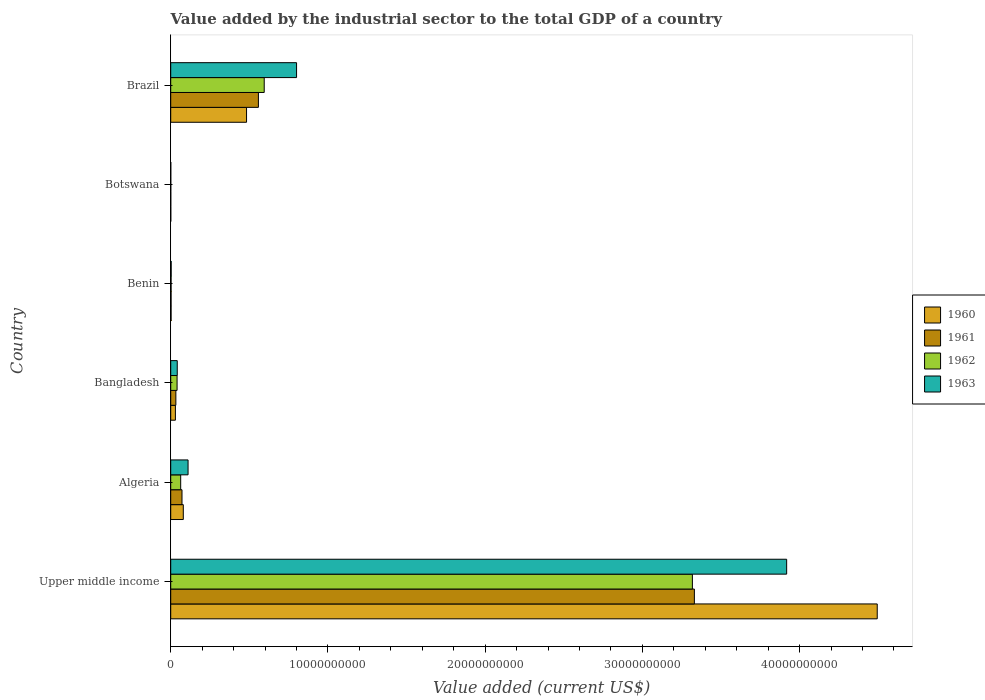How many different coloured bars are there?
Make the answer very short. 4. What is the label of the 4th group of bars from the top?
Your answer should be very brief. Bangladesh. What is the value added by the industrial sector to the total GDP in 1963 in Upper middle income?
Your answer should be compact. 3.92e+1. Across all countries, what is the maximum value added by the industrial sector to the total GDP in 1961?
Provide a succinct answer. 3.33e+1. Across all countries, what is the minimum value added by the industrial sector to the total GDP in 1962?
Your answer should be very brief. 4.05e+06. In which country was the value added by the industrial sector to the total GDP in 1963 maximum?
Ensure brevity in your answer.  Upper middle income. In which country was the value added by the industrial sector to the total GDP in 1961 minimum?
Give a very brief answer. Botswana. What is the total value added by the industrial sector to the total GDP in 1963 in the graph?
Your response must be concise. 4.87e+1. What is the difference between the value added by the industrial sector to the total GDP in 1962 in Benin and that in Botswana?
Make the answer very short. 1.91e+07. What is the difference between the value added by the industrial sector to the total GDP in 1963 in Botswana and the value added by the industrial sector to the total GDP in 1961 in Upper middle income?
Ensure brevity in your answer.  -3.33e+1. What is the average value added by the industrial sector to the total GDP in 1963 per country?
Offer a terse response. 8.12e+09. What is the difference between the value added by the industrial sector to the total GDP in 1960 and value added by the industrial sector to the total GDP in 1962 in Benin?
Keep it short and to the point. -1.71e+04. In how many countries, is the value added by the industrial sector to the total GDP in 1962 greater than 32000000000 US$?
Your answer should be compact. 1. What is the ratio of the value added by the industrial sector to the total GDP in 1960 in Benin to that in Botswana?
Offer a terse response. 5.71. What is the difference between the highest and the second highest value added by the industrial sector to the total GDP in 1961?
Offer a terse response. 2.77e+1. What is the difference between the highest and the lowest value added by the industrial sector to the total GDP in 1962?
Offer a terse response. 3.32e+1. In how many countries, is the value added by the industrial sector to the total GDP in 1961 greater than the average value added by the industrial sector to the total GDP in 1961 taken over all countries?
Provide a succinct answer. 1. Is the sum of the value added by the industrial sector to the total GDP in 1961 in Bangladesh and Upper middle income greater than the maximum value added by the industrial sector to the total GDP in 1962 across all countries?
Offer a terse response. Yes. Is it the case that in every country, the sum of the value added by the industrial sector to the total GDP in 1963 and value added by the industrial sector to the total GDP in 1961 is greater than the sum of value added by the industrial sector to the total GDP in 1962 and value added by the industrial sector to the total GDP in 1960?
Make the answer very short. No. What does the 3rd bar from the bottom in Brazil represents?
Keep it short and to the point. 1962. Is it the case that in every country, the sum of the value added by the industrial sector to the total GDP in 1963 and value added by the industrial sector to the total GDP in 1961 is greater than the value added by the industrial sector to the total GDP in 1960?
Your answer should be compact. Yes. Are all the bars in the graph horizontal?
Your answer should be compact. Yes. How many countries are there in the graph?
Your answer should be compact. 6. How are the legend labels stacked?
Provide a succinct answer. Vertical. What is the title of the graph?
Your response must be concise. Value added by the industrial sector to the total GDP of a country. What is the label or title of the X-axis?
Give a very brief answer. Value added (current US$). What is the Value added (current US$) in 1960 in Upper middle income?
Your answer should be compact. 4.49e+1. What is the Value added (current US$) of 1961 in Upper middle income?
Provide a succinct answer. 3.33e+1. What is the Value added (current US$) of 1962 in Upper middle income?
Offer a very short reply. 3.32e+1. What is the Value added (current US$) in 1963 in Upper middle income?
Ensure brevity in your answer.  3.92e+1. What is the Value added (current US$) in 1960 in Algeria?
Provide a succinct answer. 8.00e+08. What is the Value added (current US$) of 1961 in Algeria?
Your answer should be compact. 7.17e+08. What is the Value added (current US$) of 1962 in Algeria?
Ensure brevity in your answer.  6.34e+08. What is the Value added (current US$) in 1963 in Algeria?
Keep it short and to the point. 1.10e+09. What is the Value added (current US$) of 1960 in Bangladesh?
Give a very brief answer. 2.98e+08. What is the Value added (current US$) of 1961 in Bangladesh?
Give a very brief answer. 3.27e+08. What is the Value added (current US$) in 1962 in Bangladesh?
Make the answer very short. 4.05e+08. What is the Value added (current US$) of 1963 in Bangladesh?
Your response must be concise. 4.15e+08. What is the Value added (current US$) of 1960 in Benin?
Make the answer very short. 2.31e+07. What is the Value added (current US$) in 1961 in Benin?
Ensure brevity in your answer.  2.31e+07. What is the Value added (current US$) of 1962 in Benin?
Your answer should be very brief. 2.32e+07. What is the Value added (current US$) in 1963 in Benin?
Your answer should be very brief. 2.91e+07. What is the Value added (current US$) in 1960 in Botswana?
Your answer should be compact. 4.05e+06. What is the Value added (current US$) of 1961 in Botswana?
Provide a succinct answer. 4.05e+06. What is the Value added (current US$) in 1962 in Botswana?
Provide a short and direct response. 4.05e+06. What is the Value added (current US$) of 1963 in Botswana?
Keep it short and to the point. 4.04e+06. What is the Value added (current US$) of 1960 in Brazil?
Your response must be concise. 4.82e+09. What is the Value added (current US$) in 1961 in Brazil?
Your response must be concise. 5.58e+09. What is the Value added (current US$) in 1962 in Brazil?
Ensure brevity in your answer.  5.95e+09. What is the Value added (current US$) in 1963 in Brazil?
Offer a terse response. 8.00e+09. Across all countries, what is the maximum Value added (current US$) of 1960?
Offer a very short reply. 4.49e+1. Across all countries, what is the maximum Value added (current US$) of 1961?
Give a very brief answer. 3.33e+1. Across all countries, what is the maximum Value added (current US$) in 1962?
Offer a very short reply. 3.32e+1. Across all countries, what is the maximum Value added (current US$) of 1963?
Make the answer very short. 3.92e+1. Across all countries, what is the minimum Value added (current US$) in 1960?
Your answer should be compact. 4.05e+06. Across all countries, what is the minimum Value added (current US$) of 1961?
Offer a terse response. 4.05e+06. Across all countries, what is the minimum Value added (current US$) of 1962?
Your answer should be compact. 4.05e+06. Across all countries, what is the minimum Value added (current US$) in 1963?
Provide a succinct answer. 4.04e+06. What is the total Value added (current US$) in 1960 in the graph?
Offer a terse response. 5.09e+1. What is the total Value added (current US$) in 1961 in the graph?
Offer a very short reply. 4.00e+1. What is the total Value added (current US$) of 1962 in the graph?
Your answer should be compact. 4.02e+1. What is the total Value added (current US$) in 1963 in the graph?
Provide a short and direct response. 4.87e+1. What is the difference between the Value added (current US$) in 1960 in Upper middle income and that in Algeria?
Provide a succinct answer. 4.41e+1. What is the difference between the Value added (current US$) of 1961 in Upper middle income and that in Algeria?
Provide a short and direct response. 3.26e+1. What is the difference between the Value added (current US$) of 1962 in Upper middle income and that in Algeria?
Offer a very short reply. 3.25e+1. What is the difference between the Value added (current US$) in 1963 in Upper middle income and that in Algeria?
Provide a short and direct response. 3.81e+1. What is the difference between the Value added (current US$) of 1960 in Upper middle income and that in Bangladesh?
Keep it short and to the point. 4.46e+1. What is the difference between the Value added (current US$) of 1961 in Upper middle income and that in Bangladesh?
Offer a terse response. 3.30e+1. What is the difference between the Value added (current US$) in 1962 in Upper middle income and that in Bangladesh?
Ensure brevity in your answer.  3.28e+1. What is the difference between the Value added (current US$) in 1963 in Upper middle income and that in Bangladesh?
Ensure brevity in your answer.  3.88e+1. What is the difference between the Value added (current US$) of 1960 in Upper middle income and that in Benin?
Your answer should be compact. 4.49e+1. What is the difference between the Value added (current US$) of 1961 in Upper middle income and that in Benin?
Keep it short and to the point. 3.33e+1. What is the difference between the Value added (current US$) of 1962 in Upper middle income and that in Benin?
Provide a succinct answer. 3.32e+1. What is the difference between the Value added (current US$) of 1963 in Upper middle income and that in Benin?
Your response must be concise. 3.91e+1. What is the difference between the Value added (current US$) of 1960 in Upper middle income and that in Botswana?
Your response must be concise. 4.49e+1. What is the difference between the Value added (current US$) in 1961 in Upper middle income and that in Botswana?
Your answer should be very brief. 3.33e+1. What is the difference between the Value added (current US$) in 1962 in Upper middle income and that in Botswana?
Your answer should be compact. 3.32e+1. What is the difference between the Value added (current US$) of 1963 in Upper middle income and that in Botswana?
Ensure brevity in your answer.  3.92e+1. What is the difference between the Value added (current US$) of 1960 in Upper middle income and that in Brazil?
Offer a terse response. 4.01e+1. What is the difference between the Value added (current US$) of 1961 in Upper middle income and that in Brazil?
Ensure brevity in your answer.  2.77e+1. What is the difference between the Value added (current US$) of 1962 in Upper middle income and that in Brazil?
Ensure brevity in your answer.  2.72e+1. What is the difference between the Value added (current US$) in 1963 in Upper middle income and that in Brazil?
Keep it short and to the point. 3.12e+1. What is the difference between the Value added (current US$) of 1960 in Algeria and that in Bangladesh?
Ensure brevity in your answer.  5.02e+08. What is the difference between the Value added (current US$) of 1961 in Algeria and that in Bangladesh?
Offer a terse response. 3.90e+08. What is the difference between the Value added (current US$) of 1962 in Algeria and that in Bangladesh?
Offer a very short reply. 2.30e+08. What is the difference between the Value added (current US$) of 1963 in Algeria and that in Bangladesh?
Your answer should be compact. 6.88e+08. What is the difference between the Value added (current US$) in 1960 in Algeria and that in Benin?
Provide a succinct answer. 7.77e+08. What is the difference between the Value added (current US$) of 1961 in Algeria and that in Benin?
Ensure brevity in your answer.  6.94e+08. What is the difference between the Value added (current US$) in 1962 in Algeria and that in Benin?
Provide a short and direct response. 6.11e+08. What is the difference between the Value added (current US$) in 1963 in Algeria and that in Benin?
Your answer should be very brief. 1.07e+09. What is the difference between the Value added (current US$) in 1960 in Algeria and that in Botswana?
Offer a very short reply. 7.96e+08. What is the difference between the Value added (current US$) in 1961 in Algeria and that in Botswana?
Your response must be concise. 7.13e+08. What is the difference between the Value added (current US$) of 1962 in Algeria and that in Botswana?
Offer a terse response. 6.30e+08. What is the difference between the Value added (current US$) of 1963 in Algeria and that in Botswana?
Provide a short and direct response. 1.10e+09. What is the difference between the Value added (current US$) of 1960 in Algeria and that in Brazil?
Your answer should be compact. -4.02e+09. What is the difference between the Value added (current US$) in 1961 in Algeria and that in Brazil?
Your response must be concise. -4.86e+09. What is the difference between the Value added (current US$) of 1962 in Algeria and that in Brazil?
Your answer should be compact. -5.31e+09. What is the difference between the Value added (current US$) in 1963 in Algeria and that in Brazil?
Make the answer very short. -6.90e+09. What is the difference between the Value added (current US$) in 1960 in Bangladesh and that in Benin?
Keep it short and to the point. 2.75e+08. What is the difference between the Value added (current US$) in 1961 in Bangladesh and that in Benin?
Keep it short and to the point. 3.04e+08. What is the difference between the Value added (current US$) of 1962 in Bangladesh and that in Benin?
Your response must be concise. 3.82e+08. What is the difference between the Value added (current US$) in 1963 in Bangladesh and that in Benin?
Your response must be concise. 3.86e+08. What is the difference between the Value added (current US$) of 1960 in Bangladesh and that in Botswana?
Your answer should be compact. 2.94e+08. What is the difference between the Value added (current US$) of 1961 in Bangladesh and that in Botswana?
Your response must be concise. 3.23e+08. What is the difference between the Value added (current US$) in 1962 in Bangladesh and that in Botswana?
Give a very brief answer. 4.01e+08. What is the difference between the Value added (current US$) in 1963 in Bangladesh and that in Botswana?
Provide a short and direct response. 4.11e+08. What is the difference between the Value added (current US$) in 1960 in Bangladesh and that in Brazil?
Offer a very short reply. -4.52e+09. What is the difference between the Value added (current US$) of 1961 in Bangladesh and that in Brazil?
Give a very brief answer. -5.25e+09. What is the difference between the Value added (current US$) in 1962 in Bangladesh and that in Brazil?
Provide a short and direct response. -5.54e+09. What is the difference between the Value added (current US$) in 1963 in Bangladesh and that in Brazil?
Offer a terse response. -7.59e+09. What is the difference between the Value added (current US$) in 1960 in Benin and that in Botswana?
Provide a short and direct response. 1.91e+07. What is the difference between the Value added (current US$) in 1961 in Benin and that in Botswana?
Your answer should be compact. 1.91e+07. What is the difference between the Value added (current US$) in 1962 in Benin and that in Botswana?
Offer a terse response. 1.91e+07. What is the difference between the Value added (current US$) of 1963 in Benin and that in Botswana?
Provide a succinct answer. 2.51e+07. What is the difference between the Value added (current US$) in 1960 in Benin and that in Brazil?
Offer a very short reply. -4.80e+09. What is the difference between the Value added (current US$) of 1961 in Benin and that in Brazil?
Your answer should be very brief. -5.55e+09. What is the difference between the Value added (current US$) of 1962 in Benin and that in Brazil?
Keep it short and to the point. -5.92e+09. What is the difference between the Value added (current US$) in 1963 in Benin and that in Brazil?
Your response must be concise. -7.97e+09. What is the difference between the Value added (current US$) of 1960 in Botswana and that in Brazil?
Provide a succinct answer. -4.82e+09. What is the difference between the Value added (current US$) of 1961 in Botswana and that in Brazil?
Provide a succinct answer. -5.57e+09. What is the difference between the Value added (current US$) of 1962 in Botswana and that in Brazil?
Make the answer very short. -5.94e+09. What is the difference between the Value added (current US$) of 1963 in Botswana and that in Brazil?
Keep it short and to the point. -8.00e+09. What is the difference between the Value added (current US$) of 1960 in Upper middle income and the Value added (current US$) of 1961 in Algeria?
Offer a terse response. 4.42e+1. What is the difference between the Value added (current US$) of 1960 in Upper middle income and the Value added (current US$) of 1962 in Algeria?
Your answer should be very brief. 4.43e+1. What is the difference between the Value added (current US$) in 1960 in Upper middle income and the Value added (current US$) in 1963 in Algeria?
Provide a short and direct response. 4.38e+1. What is the difference between the Value added (current US$) of 1961 in Upper middle income and the Value added (current US$) of 1962 in Algeria?
Offer a very short reply. 3.27e+1. What is the difference between the Value added (current US$) in 1961 in Upper middle income and the Value added (current US$) in 1963 in Algeria?
Offer a terse response. 3.22e+1. What is the difference between the Value added (current US$) in 1962 in Upper middle income and the Value added (current US$) in 1963 in Algeria?
Provide a short and direct response. 3.21e+1. What is the difference between the Value added (current US$) of 1960 in Upper middle income and the Value added (current US$) of 1961 in Bangladesh?
Your answer should be compact. 4.46e+1. What is the difference between the Value added (current US$) of 1960 in Upper middle income and the Value added (current US$) of 1962 in Bangladesh?
Your response must be concise. 4.45e+1. What is the difference between the Value added (current US$) of 1960 in Upper middle income and the Value added (current US$) of 1963 in Bangladesh?
Your response must be concise. 4.45e+1. What is the difference between the Value added (current US$) in 1961 in Upper middle income and the Value added (current US$) in 1962 in Bangladesh?
Keep it short and to the point. 3.29e+1. What is the difference between the Value added (current US$) in 1961 in Upper middle income and the Value added (current US$) in 1963 in Bangladesh?
Your response must be concise. 3.29e+1. What is the difference between the Value added (current US$) of 1962 in Upper middle income and the Value added (current US$) of 1963 in Bangladesh?
Offer a terse response. 3.28e+1. What is the difference between the Value added (current US$) in 1960 in Upper middle income and the Value added (current US$) in 1961 in Benin?
Give a very brief answer. 4.49e+1. What is the difference between the Value added (current US$) of 1960 in Upper middle income and the Value added (current US$) of 1962 in Benin?
Keep it short and to the point. 4.49e+1. What is the difference between the Value added (current US$) of 1960 in Upper middle income and the Value added (current US$) of 1963 in Benin?
Ensure brevity in your answer.  4.49e+1. What is the difference between the Value added (current US$) in 1961 in Upper middle income and the Value added (current US$) in 1962 in Benin?
Keep it short and to the point. 3.33e+1. What is the difference between the Value added (current US$) in 1961 in Upper middle income and the Value added (current US$) in 1963 in Benin?
Make the answer very short. 3.33e+1. What is the difference between the Value added (current US$) in 1962 in Upper middle income and the Value added (current US$) in 1963 in Benin?
Your response must be concise. 3.31e+1. What is the difference between the Value added (current US$) in 1960 in Upper middle income and the Value added (current US$) in 1961 in Botswana?
Keep it short and to the point. 4.49e+1. What is the difference between the Value added (current US$) of 1960 in Upper middle income and the Value added (current US$) of 1962 in Botswana?
Provide a succinct answer. 4.49e+1. What is the difference between the Value added (current US$) of 1960 in Upper middle income and the Value added (current US$) of 1963 in Botswana?
Keep it short and to the point. 4.49e+1. What is the difference between the Value added (current US$) of 1961 in Upper middle income and the Value added (current US$) of 1962 in Botswana?
Keep it short and to the point. 3.33e+1. What is the difference between the Value added (current US$) in 1961 in Upper middle income and the Value added (current US$) in 1963 in Botswana?
Provide a short and direct response. 3.33e+1. What is the difference between the Value added (current US$) in 1962 in Upper middle income and the Value added (current US$) in 1963 in Botswana?
Your answer should be very brief. 3.32e+1. What is the difference between the Value added (current US$) in 1960 in Upper middle income and the Value added (current US$) in 1961 in Brazil?
Provide a succinct answer. 3.94e+1. What is the difference between the Value added (current US$) in 1960 in Upper middle income and the Value added (current US$) in 1962 in Brazil?
Offer a terse response. 3.90e+1. What is the difference between the Value added (current US$) in 1960 in Upper middle income and the Value added (current US$) in 1963 in Brazil?
Give a very brief answer. 3.69e+1. What is the difference between the Value added (current US$) in 1961 in Upper middle income and the Value added (current US$) in 1962 in Brazil?
Your response must be concise. 2.74e+1. What is the difference between the Value added (current US$) of 1961 in Upper middle income and the Value added (current US$) of 1963 in Brazil?
Your answer should be very brief. 2.53e+1. What is the difference between the Value added (current US$) in 1962 in Upper middle income and the Value added (current US$) in 1963 in Brazil?
Provide a short and direct response. 2.52e+1. What is the difference between the Value added (current US$) of 1960 in Algeria and the Value added (current US$) of 1961 in Bangladesh?
Offer a terse response. 4.73e+08. What is the difference between the Value added (current US$) of 1960 in Algeria and the Value added (current US$) of 1962 in Bangladesh?
Make the answer very short. 3.95e+08. What is the difference between the Value added (current US$) of 1960 in Algeria and the Value added (current US$) of 1963 in Bangladesh?
Your answer should be very brief. 3.85e+08. What is the difference between the Value added (current US$) in 1961 in Algeria and the Value added (current US$) in 1962 in Bangladesh?
Provide a succinct answer. 3.12e+08. What is the difference between the Value added (current US$) in 1961 in Algeria and the Value added (current US$) in 1963 in Bangladesh?
Make the answer very short. 3.02e+08. What is the difference between the Value added (current US$) of 1962 in Algeria and the Value added (current US$) of 1963 in Bangladesh?
Provide a succinct answer. 2.19e+08. What is the difference between the Value added (current US$) in 1960 in Algeria and the Value added (current US$) in 1961 in Benin?
Keep it short and to the point. 7.77e+08. What is the difference between the Value added (current US$) of 1960 in Algeria and the Value added (current US$) of 1962 in Benin?
Your answer should be very brief. 7.77e+08. What is the difference between the Value added (current US$) of 1960 in Algeria and the Value added (current US$) of 1963 in Benin?
Give a very brief answer. 7.71e+08. What is the difference between the Value added (current US$) of 1961 in Algeria and the Value added (current US$) of 1962 in Benin?
Your answer should be very brief. 6.94e+08. What is the difference between the Value added (current US$) of 1961 in Algeria and the Value added (current US$) of 1963 in Benin?
Keep it short and to the point. 6.88e+08. What is the difference between the Value added (current US$) in 1962 in Algeria and the Value added (current US$) in 1963 in Benin?
Ensure brevity in your answer.  6.05e+08. What is the difference between the Value added (current US$) of 1960 in Algeria and the Value added (current US$) of 1961 in Botswana?
Provide a short and direct response. 7.96e+08. What is the difference between the Value added (current US$) in 1960 in Algeria and the Value added (current US$) in 1962 in Botswana?
Your answer should be very brief. 7.96e+08. What is the difference between the Value added (current US$) in 1960 in Algeria and the Value added (current US$) in 1963 in Botswana?
Keep it short and to the point. 7.96e+08. What is the difference between the Value added (current US$) in 1961 in Algeria and the Value added (current US$) in 1962 in Botswana?
Offer a very short reply. 7.13e+08. What is the difference between the Value added (current US$) in 1961 in Algeria and the Value added (current US$) in 1963 in Botswana?
Ensure brevity in your answer.  7.13e+08. What is the difference between the Value added (current US$) of 1962 in Algeria and the Value added (current US$) of 1963 in Botswana?
Your answer should be very brief. 6.30e+08. What is the difference between the Value added (current US$) of 1960 in Algeria and the Value added (current US$) of 1961 in Brazil?
Provide a short and direct response. -4.78e+09. What is the difference between the Value added (current US$) of 1960 in Algeria and the Value added (current US$) of 1962 in Brazil?
Your answer should be very brief. -5.15e+09. What is the difference between the Value added (current US$) of 1960 in Algeria and the Value added (current US$) of 1963 in Brazil?
Offer a terse response. -7.20e+09. What is the difference between the Value added (current US$) in 1961 in Algeria and the Value added (current US$) in 1962 in Brazil?
Make the answer very short. -5.23e+09. What is the difference between the Value added (current US$) in 1961 in Algeria and the Value added (current US$) in 1963 in Brazil?
Keep it short and to the point. -7.29e+09. What is the difference between the Value added (current US$) in 1962 in Algeria and the Value added (current US$) in 1963 in Brazil?
Provide a succinct answer. -7.37e+09. What is the difference between the Value added (current US$) of 1960 in Bangladesh and the Value added (current US$) of 1961 in Benin?
Your answer should be compact. 2.75e+08. What is the difference between the Value added (current US$) in 1960 in Bangladesh and the Value added (current US$) in 1962 in Benin?
Ensure brevity in your answer.  2.75e+08. What is the difference between the Value added (current US$) of 1960 in Bangladesh and the Value added (current US$) of 1963 in Benin?
Your answer should be compact. 2.69e+08. What is the difference between the Value added (current US$) in 1961 in Bangladesh and the Value added (current US$) in 1962 in Benin?
Give a very brief answer. 3.04e+08. What is the difference between the Value added (current US$) in 1961 in Bangladesh and the Value added (current US$) in 1963 in Benin?
Provide a short and direct response. 2.98e+08. What is the difference between the Value added (current US$) of 1962 in Bangladesh and the Value added (current US$) of 1963 in Benin?
Provide a short and direct response. 3.76e+08. What is the difference between the Value added (current US$) of 1960 in Bangladesh and the Value added (current US$) of 1961 in Botswana?
Your answer should be very brief. 2.94e+08. What is the difference between the Value added (current US$) of 1960 in Bangladesh and the Value added (current US$) of 1962 in Botswana?
Offer a terse response. 2.94e+08. What is the difference between the Value added (current US$) in 1960 in Bangladesh and the Value added (current US$) in 1963 in Botswana?
Give a very brief answer. 2.94e+08. What is the difference between the Value added (current US$) in 1961 in Bangladesh and the Value added (current US$) in 1962 in Botswana?
Provide a short and direct response. 3.23e+08. What is the difference between the Value added (current US$) in 1961 in Bangladesh and the Value added (current US$) in 1963 in Botswana?
Ensure brevity in your answer.  3.23e+08. What is the difference between the Value added (current US$) in 1962 in Bangladesh and the Value added (current US$) in 1963 in Botswana?
Make the answer very short. 4.01e+08. What is the difference between the Value added (current US$) in 1960 in Bangladesh and the Value added (current US$) in 1961 in Brazil?
Your answer should be very brief. -5.28e+09. What is the difference between the Value added (current US$) of 1960 in Bangladesh and the Value added (current US$) of 1962 in Brazil?
Your answer should be very brief. -5.65e+09. What is the difference between the Value added (current US$) of 1960 in Bangladesh and the Value added (current US$) of 1963 in Brazil?
Your response must be concise. -7.71e+09. What is the difference between the Value added (current US$) of 1961 in Bangladesh and the Value added (current US$) of 1962 in Brazil?
Your answer should be very brief. -5.62e+09. What is the difference between the Value added (current US$) in 1961 in Bangladesh and the Value added (current US$) in 1963 in Brazil?
Your answer should be compact. -7.68e+09. What is the difference between the Value added (current US$) in 1962 in Bangladesh and the Value added (current US$) in 1963 in Brazil?
Give a very brief answer. -7.60e+09. What is the difference between the Value added (current US$) of 1960 in Benin and the Value added (current US$) of 1961 in Botswana?
Offer a very short reply. 1.91e+07. What is the difference between the Value added (current US$) in 1960 in Benin and the Value added (current US$) in 1962 in Botswana?
Offer a very short reply. 1.91e+07. What is the difference between the Value added (current US$) in 1960 in Benin and the Value added (current US$) in 1963 in Botswana?
Keep it short and to the point. 1.91e+07. What is the difference between the Value added (current US$) of 1961 in Benin and the Value added (current US$) of 1962 in Botswana?
Offer a terse response. 1.91e+07. What is the difference between the Value added (current US$) of 1961 in Benin and the Value added (current US$) of 1963 in Botswana?
Offer a very short reply. 1.91e+07. What is the difference between the Value added (current US$) of 1962 in Benin and the Value added (current US$) of 1963 in Botswana?
Provide a short and direct response. 1.91e+07. What is the difference between the Value added (current US$) in 1960 in Benin and the Value added (current US$) in 1961 in Brazil?
Offer a terse response. -5.55e+09. What is the difference between the Value added (current US$) in 1960 in Benin and the Value added (current US$) in 1962 in Brazil?
Ensure brevity in your answer.  -5.92e+09. What is the difference between the Value added (current US$) in 1960 in Benin and the Value added (current US$) in 1963 in Brazil?
Your answer should be very brief. -7.98e+09. What is the difference between the Value added (current US$) of 1961 in Benin and the Value added (current US$) of 1962 in Brazil?
Offer a terse response. -5.92e+09. What is the difference between the Value added (current US$) in 1961 in Benin and the Value added (current US$) in 1963 in Brazil?
Offer a terse response. -7.98e+09. What is the difference between the Value added (current US$) of 1962 in Benin and the Value added (current US$) of 1963 in Brazil?
Keep it short and to the point. -7.98e+09. What is the difference between the Value added (current US$) in 1960 in Botswana and the Value added (current US$) in 1961 in Brazil?
Offer a terse response. -5.57e+09. What is the difference between the Value added (current US$) in 1960 in Botswana and the Value added (current US$) in 1962 in Brazil?
Offer a very short reply. -5.94e+09. What is the difference between the Value added (current US$) in 1960 in Botswana and the Value added (current US$) in 1963 in Brazil?
Offer a terse response. -8.00e+09. What is the difference between the Value added (current US$) in 1961 in Botswana and the Value added (current US$) in 1962 in Brazil?
Your response must be concise. -5.94e+09. What is the difference between the Value added (current US$) of 1961 in Botswana and the Value added (current US$) of 1963 in Brazil?
Offer a terse response. -8.00e+09. What is the difference between the Value added (current US$) of 1962 in Botswana and the Value added (current US$) of 1963 in Brazil?
Provide a short and direct response. -8.00e+09. What is the average Value added (current US$) in 1960 per country?
Your answer should be very brief. 8.48e+09. What is the average Value added (current US$) of 1961 per country?
Keep it short and to the point. 6.66e+09. What is the average Value added (current US$) of 1962 per country?
Provide a short and direct response. 6.70e+09. What is the average Value added (current US$) in 1963 per country?
Your answer should be very brief. 8.12e+09. What is the difference between the Value added (current US$) of 1960 and Value added (current US$) of 1961 in Upper middle income?
Give a very brief answer. 1.16e+1. What is the difference between the Value added (current US$) in 1960 and Value added (current US$) in 1962 in Upper middle income?
Provide a short and direct response. 1.18e+1. What is the difference between the Value added (current US$) in 1960 and Value added (current US$) in 1963 in Upper middle income?
Give a very brief answer. 5.76e+09. What is the difference between the Value added (current US$) in 1961 and Value added (current US$) in 1962 in Upper middle income?
Your answer should be very brief. 1.26e+08. What is the difference between the Value added (current US$) of 1961 and Value added (current US$) of 1963 in Upper middle income?
Your answer should be very brief. -5.87e+09. What is the difference between the Value added (current US$) of 1962 and Value added (current US$) of 1963 in Upper middle income?
Give a very brief answer. -5.99e+09. What is the difference between the Value added (current US$) in 1960 and Value added (current US$) in 1961 in Algeria?
Provide a short and direct response. 8.27e+07. What is the difference between the Value added (current US$) in 1960 and Value added (current US$) in 1962 in Algeria?
Offer a terse response. 1.65e+08. What is the difference between the Value added (current US$) in 1960 and Value added (current US$) in 1963 in Algeria?
Your answer should be compact. -3.03e+08. What is the difference between the Value added (current US$) in 1961 and Value added (current US$) in 1962 in Algeria?
Offer a terse response. 8.27e+07. What is the difference between the Value added (current US$) in 1961 and Value added (current US$) in 1963 in Algeria?
Your answer should be very brief. -3.86e+08. What is the difference between the Value added (current US$) of 1962 and Value added (current US$) of 1963 in Algeria?
Your answer should be very brief. -4.69e+08. What is the difference between the Value added (current US$) of 1960 and Value added (current US$) of 1961 in Bangladesh?
Your response must be concise. -2.92e+07. What is the difference between the Value added (current US$) of 1960 and Value added (current US$) of 1962 in Bangladesh?
Make the answer very short. -1.07e+08. What is the difference between the Value added (current US$) of 1960 and Value added (current US$) of 1963 in Bangladesh?
Make the answer very short. -1.17e+08. What is the difference between the Value added (current US$) of 1961 and Value added (current US$) of 1962 in Bangladesh?
Your answer should be compact. -7.74e+07. What is the difference between the Value added (current US$) in 1961 and Value added (current US$) in 1963 in Bangladesh?
Your answer should be very brief. -8.78e+07. What is the difference between the Value added (current US$) in 1962 and Value added (current US$) in 1963 in Bangladesh?
Give a very brief answer. -1.05e+07. What is the difference between the Value added (current US$) of 1960 and Value added (current US$) of 1961 in Benin?
Make the answer very short. 6130.83. What is the difference between the Value added (current US$) in 1960 and Value added (current US$) in 1962 in Benin?
Offer a terse response. -1.71e+04. What is the difference between the Value added (current US$) of 1960 and Value added (current US$) of 1963 in Benin?
Offer a very short reply. -5.99e+06. What is the difference between the Value added (current US$) of 1961 and Value added (current US$) of 1962 in Benin?
Provide a succinct answer. -2.32e+04. What is the difference between the Value added (current US$) in 1961 and Value added (current US$) in 1963 in Benin?
Provide a short and direct response. -6.00e+06. What is the difference between the Value added (current US$) of 1962 and Value added (current US$) of 1963 in Benin?
Your answer should be very brief. -5.97e+06. What is the difference between the Value added (current US$) in 1960 and Value added (current US$) in 1961 in Botswana?
Offer a terse response. 7791.27. What is the difference between the Value added (current US$) in 1960 and Value added (current US$) in 1962 in Botswana?
Provide a succinct answer. -314.81. What is the difference between the Value added (current US$) in 1960 and Value added (current US$) in 1963 in Botswana?
Offer a very short reply. 1.11e+04. What is the difference between the Value added (current US$) in 1961 and Value added (current US$) in 1962 in Botswana?
Give a very brief answer. -8106.08. What is the difference between the Value added (current US$) of 1961 and Value added (current US$) of 1963 in Botswana?
Give a very brief answer. 3353.04. What is the difference between the Value added (current US$) of 1962 and Value added (current US$) of 1963 in Botswana?
Provide a succinct answer. 1.15e+04. What is the difference between the Value added (current US$) in 1960 and Value added (current US$) in 1961 in Brazil?
Make the answer very short. -7.55e+08. What is the difference between the Value added (current US$) of 1960 and Value added (current US$) of 1962 in Brazil?
Your answer should be compact. -1.12e+09. What is the difference between the Value added (current US$) of 1960 and Value added (current US$) of 1963 in Brazil?
Provide a succinct answer. -3.18e+09. What is the difference between the Value added (current US$) of 1961 and Value added (current US$) of 1962 in Brazil?
Your answer should be very brief. -3.69e+08. What is the difference between the Value added (current US$) of 1961 and Value added (current US$) of 1963 in Brazil?
Provide a short and direct response. -2.43e+09. What is the difference between the Value added (current US$) of 1962 and Value added (current US$) of 1963 in Brazil?
Your response must be concise. -2.06e+09. What is the ratio of the Value added (current US$) of 1960 in Upper middle income to that in Algeria?
Keep it short and to the point. 56.17. What is the ratio of the Value added (current US$) in 1961 in Upper middle income to that in Algeria?
Offer a terse response. 46.44. What is the ratio of the Value added (current US$) in 1962 in Upper middle income to that in Algeria?
Provide a succinct answer. 52.3. What is the ratio of the Value added (current US$) of 1963 in Upper middle income to that in Algeria?
Keep it short and to the point. 35.5. What is the ratio of the Value added (current US$) in 1960 in Upper middle income to that in Bangladesh?
Your answer should be compact. 150.72. What is the ratio of the Value added (current US$) of 1961 in Upper middle income to that in Bangladesh?
Keep it short and to the point. 101.75. What is the ratio of the Value added (current US$) in 1962 in Upper middle income to that in Bangladesh?
Your answer should be compact. 81.99. What is the ratio of the Value added (current US$) of 1963 in Upper middle income to that in Bangladesh?
Offer a terse response. 94.36. What is the ratio of the Value added (current US$) of 1960 in Upper middle income to that in Benin?
Offer a very short reply. 1942.42. What is the ratio of the Value added (current US$) in 1961 in Upper middle income to that in Benin?
Offer a very short reply. 1440.1. What is the ratio of the Value added (current US$) of 1962 in Upper middle income to that in Benin?
Make the answer very short. 1433.2. What is the ratio of the Value added (current US$) in 1963 in Upper middle income to that in Benin?
Give a very brief answer. 1345.05. What is the ratio of the Value added (current US$) in 1960 in Upper middle income to that in Botswana?
Offer a terse response. 1.11e+04. What is the ratio of the Value added (current US$) of 1961 in Upper middle income to that in Botswana?
Offer a terse response. 8231.16. What is the ratio of the Value added (current US$) in 1962 in Upper middle income to that in Botswana?
Provide a succinct answer. 8183.55. What is the ratio of the Value added (current US$) in 1963 in Upper middle income to that in Botswana?
Offer a terse response. 9689.55. What is the ratio of the Value added (current US$) of 1960 in Upper middle income to that in Brazil?
Ensure brevity in your answer.  9.32. What is the ratio of the Value added (current US$) of 1961 in Upper middle income to that in Brazil?
Give a very brief answer. 5.97. What is the ratio of the Value added (current US$) of 1962 in Upper middle income to that in Brazil?
Your answer should be very brief. 5.58. What is the ratio of the Value added (current US$) of 1963 in Upper middle income to that in Brazil?
Your answer should be very brief. 4.89. What is the ratio of the Value added (current US$) of 1960 in Algeria to that in Bangladesh?
Your answer should be compact. 2.68. What is the ratio of the Value added (current US$) of 1961 in Algeria to that in Bangladesh?
Provide a succinct answer. 2.19. What is the ratio of the Value added (current US$) of 1962 in Algeria to that in Bangladesh?
Offer a very short reply. 1.57. What is the ratio of the Value added (current US$) of 1963 in Algeria to that in Bangladesh?
Offer a terse response. 2.66. What is the ratio of the Value added (current US$) in 1960 in Algeria to that in Benin?
Offer a very short reply. 34.58. What is the ratio of the Value added (current US$) in 1961 in Algeria to that in Benin?
Offer a terse response. 31.01. What is the ratio of the Value added (current US$) of 1962 in Algeria to that in Benin?
Provide a short and direct response. 27.4. What is the ratio of the Value added (current US$) of 1963 in Algeria to that in Benin?
Keep it short and to the point. 37.88. What is the ratio of the Value added (current US$) in 1960 in Algeria to that in Botswana?
Give a very brief answer. 197.31. What is the ratio of the Value added (current US$) in 1961 in Algeria to that in Botswana?
Your response must be concise. 177.24. What is the ratio of the Value added (current US$) of 1962 in Algeria to that in Botswana?
Provide a succinct answer. 156.48. What is the ratio of the Value added (current US$) of 1963 in Algeria to that in Botswana?
Keep it short and to the point. 272.91. What is the ratio of the Value added (current US$) of 1960 in Algeria to that in Brazil?
Provide a succinct answer. 0.17. What is the ratio of the Value added (current US$) of 1961 in Algeria to that in Brazil?
Your response must be concise. 0.13. What is the ratio of the Value added (current US$) in 1962 in Algeria to that in Brazil?
Your response must be concise. 0.11. What is the ratio of the Value added (current US$) of 1963 in Algeria to that in Brazil?
Give a very brief answer. 0.14. What is the ratio of the Value added (current US$) in 1960 in Bangladesh to that in Benin?
Your answer should be compact. 12.89. What is the ratio of the Value added (current US$) in 1961 in Bangladesh to that in Benin?
Provide a succinct answer. 14.15. What is the ratio of the Value added (current US$) in 1962 in Bangladesh to that in Benin?
Keep it short and to the point. 17.48. What is the ratio of the Value added (current US$) of 1963 in Bangladesh to that in Benin?
Keep it short and to the point. 14.26. What is the ratio of the Value added (current US$) in 1960 in Bangladesh to that in Botswana?
Make the answer very short. 73.54. What is the ratio of the Value added (current US$) of 1961 in Bangladesh to that in Botswana?
Provide a succinct answer. 80.89. What is the ratio of the Value added (current US$) of 1962 in Bangladesh to that in Botswana?
Make the answer very short. 99.81. What is the ratio of the Value added (current US$) of 1963 in Bangladesh to that in Botswana?
Give a very brief answer. 102.69. What is the ratio of the Value added (current US$) of 1960 in Bangladesh to that in Brazil?
Offer a terse response. 0.06. What is the ratio of the Value added (current US$) of 1961 in Bangladesh to that in Brazil?
Keep it short and to the point. 0.06. What is the ratio of the Value added (current US$) in 1962 in Bangladesh to that in Brazil?
Ensure brevity in your answer.  0.07. What is the ratio of the Value added (current US$) in 1963 in Bangladesh to that in Brazil?
Provide a succinct answer. 0.05. What is the ratio of the Value added (current US$) in 1960 in Benin to that in Botswana?
Keep it short and to the point. 5.71. What is the ratio of the Value added (current US$) of 1961 in Benin to that in Botswana?
Make the answer very short. 5.72. What is the ratio of the Value added (current US$) in 1962 in Benin to that in Botswana?
Make the answer very short. 5.71. What is the ratio of the Value added (current US$) of 1963 in Benin to that in Botswana?
Keep it short and to the point. 7.2. What is the ratio of the Value added (current US$) of 1960 in Benin to that in Brazil?
Make the answer very short. 0. What is the ratio of the Value added (current US$) of 1961 in Benin to that in Brazil?
Make the answer very short. 0. What is the ratio of the Value added (current US$) in 1962 in Benin to that in Brazil?
Provide a succinct answer. 0. What is the ratio of the Value added (current US$) in 1963 in Benin to that in Brazil?
Your answer should be compact. 0. What is the ratio of the Value added (current US$) in 1960 in Botswana to that in Brazil?
Provide a short and direct response. 0. What is the ratio of the Value added (current US$) of 1961 in Botswana to that in Brazil?
Offer a terse response. 0. What is the ratio of the Value added (current US$) in 1962 in Botswana to that in Brazil?
Provide a succinct answer. 0. What is the difference between the highest and the second highest Value added (current US$) of 1960?
Your answer should be very brief. 4.01e+1. What is the difference between the highest and the second highest Value added (current US$) in 1961?
Provide a short and direct response. 2.77e+1. What is the difference between the highest and the second highest Value added (current US$) of 1962?
Ensure brevity in your answer.  2.72e+1. What is the difference between the highest and the second highest Value added (current US$) in 1963?
Offer a very short reply. 3.12e+1. What is the difference between the highest and the lowest Value added (current US$) of 1960?
Make the answer very short. 4.49e+1. What is the difference between the highest and the lowest Value added (current US$) of 1961?
Give a very brief answer. 3.33e+1. What is the difference between the highest and the lowest Value added (current US$) in 1962?
Make the answer very short. 3.32e+1. What is the difference between the highest and the lowest Value added (current US$) in 1963?
Offer a very short reply. 3.92e+1. 